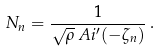Convert formula to latex. <formula><loc_0><loc_0><loc_500><loc_500>N _ { n } = \frac { 1 } { \sqrt { \rho } \, A i ^ { \prime } ( - \zeta _ { n } ) } \, .</formula> 